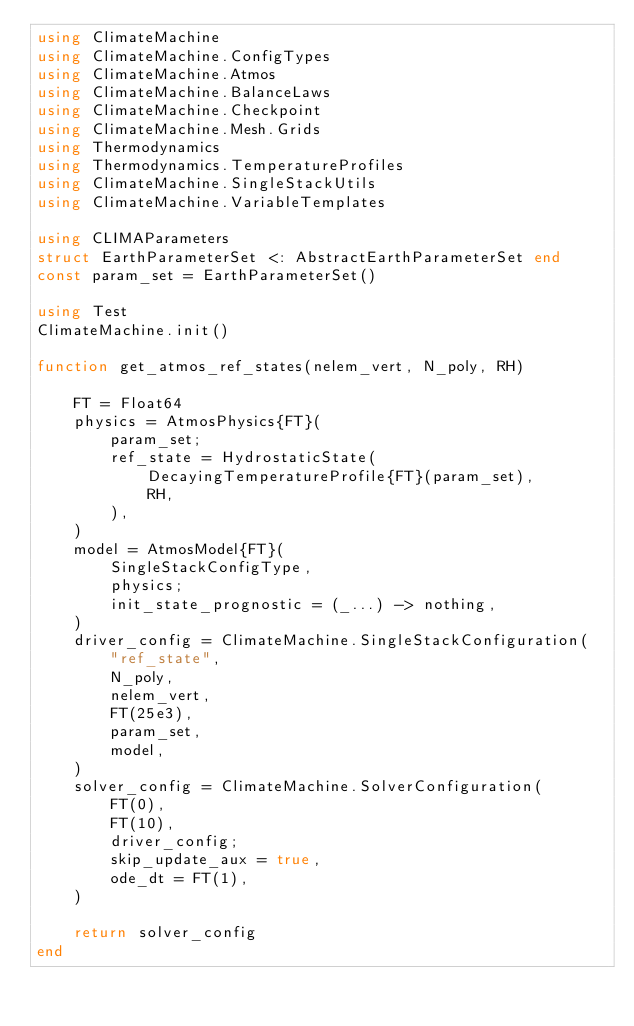Convert code to text. <code><loc_0><loc_0><loc_500><loc_500><_Julia_>using ClimateMachine
using ClimateMachine.ConfigTypes
using ClimateMachine.Atmos
using ClimateMachine.BalanceLaws
using ClimateMachine.Checkpoint
using ClimateMachine.Mesh.Grids
using Thermodynamics
using Thermodynamics.TemperatureProfiles
using ClimateMachine.SingleStackUtils
using ClimateMachine.VariableTemplates

using CLIMAParameters
struct EarthParameterSet <: AbstractEarthParameterSet end
const param_set = EarthParameterSet()

using Test
ClimateMachine.init()

function get_atmos_ref_states(nelem_vert, N_poly, RH)

    FT = Float64
    physics = AtmosPhysics{FT}(
        param_set;
        ref_state = HydrostaticState(
            DecayingTemperatureProfile{FT}(param_set),
            RH,
        ),
    )
    model = AtmosModel{FT}(
        SingleStackConfigType,
        physics;
        init_state_prognostic = (_...) -> nothing,
    )
    driver_config = ClimateMachine.SingleStackConfiguration(
        "ref_state",
        N_poly,
        nelem_vert,
        FT(25e3),
        param_set,
        model,
    )
    solver_config = ClimateMachine.SolverConfiguration(
        FT(0),
        FT(10),
        driver_config;
        skip_update_aux = true,
        ode_dt = FT(1),
    )

    return solver_config
end
</code> 